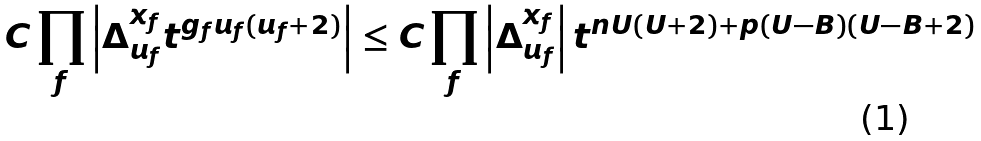Convert formula to latex. <formula><loc_0><loc_0><loc_500><loc_500>C \prod _ { f } \left | \Delta _ { u _ { f } } ^ { x _ { f } } t ^ { g _ { f } u _ { f } ( u _ { f } + 2 ) } \right | \leq C \prod _ { f } \left | \Delta _ { u _ { f } } ^ { x _ { f } } \right | t ^ { n U ( U + 2 ) + p ( U - B ) ( U - B + 2 ) }</formula> 